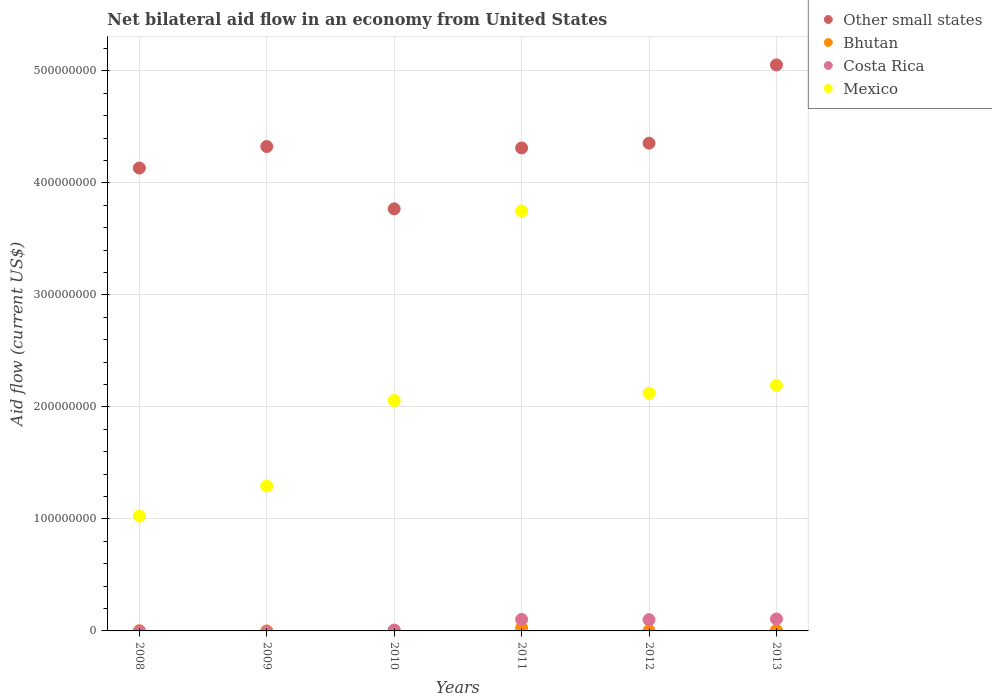How many different coloured dotlines are there?
Offer a terse response. 4. What is the net bilateral aid flow in Other small states in 2013?
Your answer should be compact. 5.05e+08. Across all years, what is the maximum net bilateral aid flow in Costa Rica?
Give a very brief answer. 1.07e+07. Across all years, what is the minimum net bilateral aid flow in Mexico?
Your answer should be very brief. 1.03e+08. What is the total net bilateral aid flow in Costa Rica in the graph?
Keep it short and to the point. 3.17e+07. What is the difference between the net bilateral aid flow in Costa Rica in 2011 and the net bilateral aid flow in Mexico in 2010?
Make the answer very short. -1.95e+08. What is the average net bilateral aid flow in Other small states per year?
Keep it short and to the point. 4.32e+08. In the year 2010, what is the difference between the net bilateral aid flow in Costa Rica and net bilateral aid flow in Mexico?
Give a very brief answer. -2.05e+08. In how many years, is the net bilateral aid flow in Mexico greater than 120000000 US$?
Your answer should be compact. 5. What is the ratio of the net bilateral aid flow in Costa Rica in 2011 to that in 2013?
Your answer should be compact. 0.96. What is the difference between the highest and the second highest net bilateral aid flow in Costa Rica?
Provide a succinct answer. 4.20e+05. What is the difference between the highest and the lowest net bilateral aid flow in Bhutan?
Make the answer very short. 2.65e+06. Is it the case that in every year, the sum of the net bilateral aid flow in Mexico and net bilateral aid flow in Costa Rica  is greater than the net bilateral aid flow in Bhutan?
Your answer should be very brief. Yes. Does the net bilateral aid flow in Bhutan monotonically increase over the years?
Keep it short and to the point. No. Is the net bilateral aid flow in Mexico strictly greater than the net bilateral aid flow in Bhutan over the years?
Provide a short and direct response. Yes. Is the net bilateral aid flow in Mexico strictly less than the net bilateral aid flow in Bhutan over the years?
Your answer should be very brief. No. What is the difference between two consecutive major ticks on the Y-axis?
Provide a succinct answer. 1.00e+08. Are the values on the major ticks of Y-axis written in scientific E-notation?
Make the answer very short. No. Does the graph contain grids?
Offer a terse response. Yes. What is the title of the graph?
Give a very brief answer. Net bilateral aid flow in an economy from United States. What is the label or title of the X-axis?
Provide a short and direct response. Years. What is the label or title of the Y-axis?
Provide a short and direct response. Aid flow (current US$). What is the Aid flow (current US$) of Other small states in 2008?
Provide a short and direct response. 4.13e+08. What is the Aid flow (current US$) of Bhutan in 2008?
Offer a terse response. 2.40e+05. What is the Aid flow (current US$) of Costa Rica in 2008?
Provide a short and direct response. 0. What is the Aid flow (current US$) of Mexico in 2008?
Your response must be concise. 1.03e+08. What is the Aid flow (current US$) in Other small states in 2009?
Ensure brevity in your answer.  4.32e+08. What is the Aid flow (current US$) of Bhutan in 2009?
Give a very brief answer. 10000. What is the Aid flow (current US$) in Costa Rica in 2009?
Make the answer very short. 0. What is the Aid flow (current US$) of Mexico in 2009?
Ensure brevity in your answer.  1.29e+08. What is the Aid flow (current US$) of Other small states in 2010?
Provide a short and direct response. 3.77e+08. What is the Aid flow (current US$) of Bhutan in 2010?
Provide a short and direct response. 6.20e+05. What is the Aid flow (current US$) in Costa Rica in 2010?
Ensure brevity in your answer.  6.90e+05. What is the Aid flow (current US$) in Mexico in 2010?
Offer a terse response. 2.06e+08. What is the Aid flow (current US$) in Other small states in 2011?
Your response must be concise. 4.31e+08. What is the Aid flow (current US$) of Bhutan in 2011?
Provide a short and direct response. 2.66e+06. What is the Aid flow (current US$) in Costa Rica in 2011?
Ensure brevity in your answer.  1.03e+07. What is the Aid flow (current US$) of Mexico in 2011?
Provide a succinct answer. 3.75e+08. What is the Aid flow (current US$) in Other small states in 2012?
Make the answer very short. 4.35e+08. What is the Aid flow (current US$) of Bhutan in 2012?
Ensure brevity in your answer.  3.00e+05. What is the Aid flow (current US$) of Costa Rica in 2012?
Provide a short and direct response. 1.01e+07. What is the Aid flow (current US$) in Mexico in 2012?
Keep it short and to the point. 2.12e+08. What is the Aid flow (current US$) in Other small states in 2013?
Your answer should be compact. 5.05e+08. What is the Aid flow (current US$) in Bhutan in 2013?
Keep it short and to the point. 5.70e+05. What is the Aid flow (current US$) in Costa Rica in 2013?
Provide a short and direct response. 1.07e+07. What is the Aid flow (current US$) of Mexico in 2013?
Provide a succinct answer. 2.19e+08. Across all years, what is the maximum Aid flow (current US$) in Other small states?
Give a very brief answer. 5.05e+08. Across all years, what is the maximum Aid flow (current US$) of Bhutan?
Keep it short and to the point. 2.66e+06. Across all years, what is the maximum Aid flow (current US$) in Costa Rica?
Your response must be concise. 1.07e+07. Across all years, what is the maximum Aid flow (current US$) of Mexico?
Your answer should be compact. 3.75e+08. Across all years, what is the minimum Aid flow (current US$) in Other small states?
Make the answer very short. 3.77e+08. Across all years, what is the minimum Aid flow (current US$) of Costa Rica?
Provide a short and direct response. 0. Across all years, what is the minimum Aid flow (current US$) in Mexico?
Your answer should be very brief. 1.03e+08. What is the total Aid flow (current US$) of Other small states in the graph?
Provide a succinct answer. 2.59e+09. What is the total Aid flow (current US$) of Bhutan in the graph?
Your answer should be compact. 4.40e+06. What is the total Aid flow (current US$) of Costa Rica in the graph?
Your answer should be compact. 3.17e+07. What is the total Aid flow (current US$) in Mexico in the graph?
Your answer should be very brief. 1.24e+09. What is the difference between the Aid flow (current US$) in Other small states in 2008 and that in 2009?
Your answer should be compact. -1.92e+07. What is the difference between the Aid flow (current US$) of Mexico in 2008 and that in 2009?
Offer a terse response. -2.69e+07. What is the difference between the Aid flow (current US$) of Other small states in 2008 and that in 2010?
Your answer should be compact. 3.64e+07. What is the difference between the Aid flow (current US$) of Bhutan in 2008 and that in 2010?
Offer a very short reply. -3.80e+05. What is the difference between the Aid flow (current US$) in Mexico in 2008 and that in 2010?
Your answer should be very brief. -1.03e+08. What is the difference between the Aid flow (current US$) of Other small states in 2008 and that in 2011?
Ensure brevity in your answer.  -1.79e+07. What is the difference between the Aid flow (current US$) of Bhutan in 2008 and that in 2011?
Give a very brief answer. -2.42e+06. What is the difference between the Aid flow (current US$) in Mexico in 2008 and that in 2011?
Keep it short and to the point. -2.72e+08. What is the difference between the Aid flow (current US$) of Other small states in 2008 and that in 2012?
Offer a very short reply. -2.22e+07. What is the difference between the Aid flow (current US$) in Bhutan in 2008 and that in 2012?
Give a very brief answer. -6.00e+04. What is the difference between the Aid flow (current US$) of Mexico in 2008 and that in 2012?
Make the answer very short. -1.10e+08. What is the difference between the Aid flow (current US$) of Other small states in 2008 and that in 2013?
Give a very brief answer. -9.20e+07. What is the difference between the Aid flow (current US$) of Bhutan in 2008 and that in 2013?
Ensure brevity in your answer.  -3.30e+05. What is the difference between the Aid flow (current US$) of Mexico in 2008 and that in 2013?
Offer a terse response. -1.17e+08. What is the difference between the Aid flow (current US$) of Other small states in 2009 and that in 2010?
Your answer should be compact. 5.56e+07. What is the difference between the Aid flow (current US$) of Bhutan in 2009 and that in 2010?
Ensure brevity in your answer.  -6.10e+05. What is the difference between the Aid flow (current US$) in Mexico in 2009 and that in 2010?
Give a very brief answer. -7.62e+07. What is the difference between the Aid flow (current US$) of Other small states in 2009 and that in 2011?
Offer a very short reply. 1.28e+06. What is the difference between the Aid flow (current US$) in Bhutan in 2009 and that in 2011?
Keep it short and to the point. -2.65e+06. What is the difference between the Aid flow (current US$) in Mexico in 2009 and that in 2011?
Keep it short and to the point. -2.45e+08. What is the difference between the Aid flow (current US$) of Other small states in 2009 and that in 2012?
Your answer should be compact. -2.97e+06. What is the difference between the Aid flow (current US$) in Bhutan in 2009 and that in 2012?
Provide a short and direct response. -2.90e+05. What is the difference between the Aid flow (current US$) of Mexico in 2009 and that in 2012?
Give a very brief answer. -8.27e+07. What is the difference between the Aid flow (current US$) in Other small states in 2009 and that in 2013?
Keep it short and to the point. -7.28e+07. What is the difference between the Aid flow (current US$) in Bhutan in 2009 and that in 2013?
Make the answer very short. -5.60e+05. What is the difference between the Aid flow (current US$) of Mexico in 2009 and that in 2013?
Your answer should be very brief. -8.97e+07. What is the difference between the Aid flow (current US$) in Other small states in 2010 and that in 2011?
Your response must be concise. -5.44e+07. What is the difference between the Aid flow (current US$) of Bhutan in 2010 and that in 2011?
Offer a terse response. -2.04e+06. What is the difference between the Aid flow (current US$) in Costa Rica in 2010 and that in 2011?
Your answer should be very brief. -9.57e+06. What is the difference between the Aid flow (current US$) in Mexico in 2010 and that in 2011?
Offer a terse response. -1.69e+08. What is the difference between the Aid flow (current US$) of Other small states in 2010 and that in 2012?
Make the answer very short. -5.86e+07. What is the difference between the Aid flow (current US$) in Costa Rica in 2010 and that in 2012?
Ensure brevity in your answer.  -9.37e+06. What is the difference between the Aid flow (current US$) in Mexico in 2010 and that in 2012?
Your answer should be very brief. -6.54e+06. What is the difference between the Aid flow (current US$) in Other small states in 2010 and that in 2013?
Provide a succinct answer. -1.28e+08. What is the difference between the Aid flow (current US$) of Costa Rica in 2010 and that in 2013?
Make the answer very short. -9.99e+06. What is the difference between the Aid flow (current US$) of Mexico in 2010 and that in 2013?
Offer a very short reply. -1.36e+07. What is the difference between the Aid flow (current US$) in Other small states in 2011 and that in 2012?
Make the answer very short. -4.25e+06. What is the difference between the Aid flow (current US$) of Bhutan in 2011 and that in 2012?
Keep it short and to the point. 2.36e+06. What is the difference between the Aid flow (current US$) in Mexico in 2011 and that in 2012?
Keep it short and to the point. 1.63e+08. What is the difference between the Aid flow (current US$) in Other small states in 2011 and that in 2013?
Your answer should be compact. -7.41e+07. What is the difference between the Aid flow (current US$) of Bhutan in 2011 and that in 2013?
Your response must be concise. 2.09e+06. What is the difference between the Aid flow (current US$) of Costa Rica in 2011 and that in 2013?
Give a very brief answer. -4.20e+05. What is the difference between the Aid flow (current US$) in Mexico in 2011 and that in 2013?
Give a very brief answer. 1.56e+08. What is the difference between the Aid flow (current US$) in Other small states in 2012 and that in 2013?
Provide a short and direct response. -6.99e+07. What is the difference between the Aid flow (current US$) in Bhutan in 2012 and that in 2013?
Give a very brief answer. -2.70e+05. What is the difference between the Aid flow (current US$) of Costa Rica in 2012 and that in 2013?
Give a very brief answer. -6.20e+05. What is the difference between the Aid flow (current US$) of Mexico in 2012 and that in 2013?
Offer a very short reply. -7.01e+06. What is the difference between the Aid flow (current US$) in Other small states in 2008 and the Aid flow (current US$) in Bhutan in 2009?
Provide a succinct answer. 4.13e+08. What is the difference between the Aid flow (current US$) of Other small states in 2008 and the Aid flow (current US$) of Mexico in 2009?
Your response must be concise. 2.84e+08. What is the difference between the Aid flow (current US$) in Bhutan in 2008 and the Aid flow (current US$) in Mexico in 2009?
Provide a short and direct response. -1.29e+08. What is the difference between the Aid flow (current US$) of Other small states in 2008 and the Aid flow (current US$) of Bhutan in 2010?
Keep it short and to the point. 4.13e+08. What is the difference between the Aid flow (current US$) in Other small states in 2008 and the Aid flow (current US$) in Costa Rica in 2010?
Offer a terse response. 4.13e+08. What is the difference between the Aid flow (current US$) of Other small states in 2008 and the Aid flow (current US$) of Mexico in 2010?
Your answer should be compact. 2.08e+08. What is the difference between the Aid flow (current US$) in Bhutan in 2008 and the Aid flow (current US$) in Costa Rica in 2010?
Ensure brevity in your answer.  -4.50e+05. What is the difference between the Aid flow (current US$) in Bhutan in 2008 and the Aid flow (current US$) in Mexico in 2010?
Your answer should be very brief. -2.05e+08. What is the difference between the Aid flow (current US$) of Other small states in 2008 and the Aid flow (current US$) of Bhutan in 2011?
Your answer should be very brief. 4.11e+08. What is the difference between the Aid flow (current US$) of Other small states in 2008 and the Aid flow (current US$) of Costa Rica in 2011?
Your answer should be compact. 4.03e+08. What is the difference between the Aid flow (current US$) of Other small states in 2008 and the Aid flow (current US$) of Mexico in 2011?
Provide a short and direct response. 3.83e+07. What is the difference between the Aid flow (current US$) in Bhutan in 2008 and the Aid flow (current US$) in Costa Rica in 2011?
Your response must be concise. -1.00e+07. What is the difference between the Aid flow (current US$) in Bhutan in 2008 and the Aid flow (current US$) in Mexico in 2011?
Offer a terse response. -3.75e+08. What is the difference between the Aid flow (current US$) in Other small states in 2008 and the Aid flow (current US$) in Bhutan in 2012?
Make the answer very short. 4.13e+08. What is the difference between the Aid flow (current US$) of Other small states in 2008 and the Aid flow (current US$) of Costa Rica in 2012?
Keep it short and to the point. 4.03e+08. What is the difference between the Aid flow (current US$) in Other small states in 2008 and the Aid flow (current US$) in Mexico in 2012?
Ensure brevity in your answer.  2.01e+08. What is the difference between the Aid flow (current US$) of Bhutan in 2008 and the Aid flow (current US$) of Costa Rica in 2012?
Give a very brief answer. -9.82e+06. What is the difference between the Aid flow (current US$) of Bhutan in 2008 and the Aid flow (current US$) of Mexico in 2012?
Provide a short and direct response. -2.12e+08. What is the difference between the Aid flow (current US$) in Other small states in 2008 and the Aid flow (current US$) in Bhutan in 2013?
Your answer should be very brief. 4.13e+08. What is the difference between the Aid flow (current US$) of Other small states in 2008 and the Aid flow (current US$) of Costa Rica in 2013?
Provide a short and direct response. 4.03e+08. What is the difference between the Aid flow (current US$) in Other small states in 2008 and the Aid flow (current US$) in Mexico in 2013?
Give a very brief answer. 1.94e+08. What is the difference between the Aid flow (current US$) of Bhutan in 2008 and the Aid flow (current US$) of Costa Rica in 2013?
Provide a succinct answer. -1.04e+07. What is the difference between the Aid flow (current US$) of Bhutan in 2008 and the Aid flow (current US$) of Mexico in 2013?
Offer a very short reply. -2.19e+08. What is the difference between the Aid flow (current US$) in Other small states in 2009 and the Aid flow (current US$) in Bhutan in 2010?
Make the answer very short. 4.32e+08. What is the difference between the Aid flow (current US$) in Other small states in 2009 and the Aid flow (current US$) in Costa Rica in 2010?
Provide a short and direct response. 4.32e+08. What is the difference between the Aid flow (current US$) of Other small states in 2009 and the Aid flow (current US$) of Mexico in 2010?
Keep it short and to the point. 2.27e+08. What is the difference between the Aid flow (current US$) of Bhutan in 2009 and the Aid flow (current US$) of Costa Rica in 2010?
Your response must be concise. -6.80e+05. What is the difference between the Aid flow (current US$) in Bhutan in 2009 and the Aid flow (current US$) in Mexico in 2010?
Give a very brief answer. -2.06e+08. What is the difference between the Aid flow (current US$) in Other small states in 2009 and the Aid flow (current US$) in Bhutan in 2011?
Keep it short and to the point. 4.30e+08. What is the difference between the Aid flow (current US$) of Other small states in 2009 and the Aid flow (current US$) of Costa Rica in 2011?
Your answer should be compact. 4.22e+08. What is the difference between the Aid flow (current US$) in Other small states in 2009 and the Aid flow (current US$) in Mexico in 2011?
Give a very brief answer. 5.75e+07. What is the difference between the Aid flow (current US$) in Bhutan in 2009 and the Aid flow (current US$) in Costa Rica in 2011?
Offer a terse response. -1.02e+07. What is the difference between the Aid flow (current US$) in Bhutan in 2009 and the Aid flow (current US$) in Mexico in 2011?
Provide a short and direct response. -3.75e+08. What is the difference between the Aid flow (current US$) in Other small states in 2009 and the Aid flow (current US$) in Bhutan in 2012?
Make the answer very short. 4.32e+08. What is the difference between the Aid flow (current US$) in Other small states in 2009 and the Aid flow (current US$) in Costa Rica in 2012?
Keep it short and to the point. 4.22e+08. What is the difference between the Aid flow (current US$) of Other small states in 2009 and the Aid flow (current US$) of Mexico in 2012?
Provide a short and direct response. 2.20e+08. What is the difference between the Aid flow (current US$) in Bhutan in 2009 and the Aid flow (current US$) in Costa Rica in 2012?
Your answer should be compact. -1.00e+07. What is the difference between the Aid flow (current US$) of Bhutan in 2009 and the Aid flow (current US$) of Mexico in 2012?
Provide a short and direct response. -2.12e+08. What is the difference between the Aid flow (current US$) in Other small states in 2009 and the Aid flow (current US$) in Bhutan in 2013?
Provide a succinct answer. 4.32e+08. What is the difference between the Aid flow (current US$) in Other small states in 2009 and the Aid flow (current US$) in Costa Rica in 2013?
Ensure brevity in your answer.  4.22e+08. What is the difference between the Aid flow (current US$) in Other small states in 2009 and the Aid flow (current US$) in Mexico in 2013?
Give a very brief answer. 2.13e+08. What is the difference between the Aid flow (current US$) in Bhutan in 2009 and the Aid flow (current US$) in Costa Rica in 2013?
Your answer should be very brief. -1.07e+07. What is the difference between the Aid flow (current US$) in Bhutan in 2009 and the Aid flow (current US$) in Mexico in 2013?
Make the answer very short. -2.19e+08. What is the difference between the Aid flow (current US$) of Other small states in 2010 and the Aid flow (current US$) of Bhutan in 2011?
Offer a very short reply. 3.74e+08. What is the difference between the Aid flow (current US$) in Other small states in 2010 and the Aid flow (current US$) in Costa Rica in 2011?
Offer a terse response. 3.66e+08. What is the difference between the Aid flow (current US$) of Other small states in 2010 and the Aid flow (current US$) of Mexico in 2011?
Provide a short and direct response. 1.87e+06. What is the difference between the Aid flow (current US$) in Bhutan in 2010 and the Aid flow (current US$) in Costa Rica in 2011?
Your response must be concise. -9.64e+06. What is the difference between the Aid flow (current US$) of Bhutan in 2010 and the Aid flow (current US$) of Mexico in 2011?
Make the answer very short. -3.74e+08. What is the difference between the Aid flow (current US$) in Costa Rica in 2010 and the Aid flow (current US$) in Mexico in 2011?
Make the answer very short. -3.74e+08. What is the difference between the Aid flow (current US$) in Other small states in 2010 and the Aid flow (current US$) in Bhutan in 2012?
Offer a terse response. 3.76e+08. What is the difference between the Aid flow (current US$) of Other small states in 2010 and the Aid flow (current US$) of Costa Rica in 2012?
Ensure brevity in your answer.  3.67e+08. What is the difference between the Aid flow (current US$) in Other small states in 2010 and the Aid flow (current US$) in Mexico in 2012?
Keep it short and to the point. 1.65e+08. What is the difference between the Aid flow (current US$) of Bhutan in 2010 and the Aid flow (current US$) of Costa Rica in 2012?
Your answer should be very brief. -9.44e+06. What is the difference between the Aid flow (current US$) in Bhutan in 2010 and the Aid flow (current US$) in Mexico in 2012?
Ensure brevity in your answer.  -2.12e+08. What is the difference between the Aid flow (current US$) of Costa Rica in 2010 and the Aid flow (current US$) of Mexico in 2012?
Make the answer very short. -2.11e+08. What is the difference between the Aid flow (current US$) of Other small states in 2010 and the Aid flow (current US$) of Bhutan in 2013?
Make the answer very short. 3.76e+08. What is the difference between the Aid flow (current US$) of Other small states in 2010 and the Aid flow (current US$) of Costa Rica in 2013?
Make the answer very short. 3.66e+08. What is the difference between the Aid flow (current US$) of Other small states in 2010 and the Aid flow (current US$) of Mexico in 2013?
Your answer should be very brief. 1.58e+08. What is the difference between the Aid flow (current US$) in Bhutan in 2010 and the Aid flow (current US$) in Costa Rica in 2013?
Your response must be concise. -1.01e+07. What is the difference between the Aid flow (current US$) in Bhutan in 2010 and the Aid flow (current US$) in Mexico in 2013?
Make the answer very short. -2.19e+08. What is the difference between the Aid flow (current US$) in Costa Rica in 2010 and the Aid flow (current US$) in Mexico in 2013?
Offer a very short reply. -2.18e+08. What is the difference between the Aid flow (current US$) of Other small states in 2011 and the Aid flow (current US$) of Bhutan in 2012?
Make the answer very short. 4.31e+08. What is the difference between the Aid flow (current US$) of Other small states in 2011 and the Aid flow (current US$) of Costa Rica in 2012?
Provide a short and direct response. 4.21e+08. What is the difference between the Aid flow (current US$) of Other small states in 2011 and the Aid flow (current US$) of Mexico in 2012?
Your answer should be very brief. 2.19e+08. What is the difference between the Aid flow (current US$) in Bhutan in 2011 and the Aid flow (current US$) in Costa Rica in 2012?
Ensure brevity in your answer.  -7.40e+06. What is the difference between the Aid flow (current US$) of Bhutan in 2011 and the Aid flow (current US$) of Mexico in 2012?
Provide a succinct answer. -2.09e+08. What is the difference between the Aid flow (current US$) in Costa Rica in 2011 and the Aid flow (current US$) in Mexico in 2012?
Ensure brevity in your answer.  -2.02e+08. What is the difference between the Aid flow (current US$) in Other small states in 2011 and the Aid flow (current US$) in Bhutan in 2013?
Your answer should be very brief. 4.31e+08. What is the difference between the Aid flow (current US$) in Other small states in 2011 and the Aid flow (current US$) in Costa Rica in 2013?
Offer a terse response. 4.20e+08. What is the difference between the Aid flow (current US$) in Other small states in 2011 and the Aid flow (current US$) in Mexico in 2013?
Your answer should be very brief. 2.12e+08. What is the difference between the Aid flow (current US$) in Bhutan in 2011 and the Aid flow (current US$) in Costa Rica in 2013?
Give a very brief answer. -8.02e+06. What is the difference between the Aid flow (current US$) in Bhutan in 2011 and the Aid flow (current US$) in Mexico in 2013?
Your answer should be very brief. -2.16e+08. What is the difference between the Aid flow (current US$) of Costa Rica in 2011 and the Aid flow (current US$) of Mexico in 2013?
Offer a very short reply. -2.09e+08. What is the difference between the Aid flow (current US$) of Other small states in 2012 and the Aid flow (current US$) of Bhutan in 2013?
Provide a short and direct response. 4.35e+08. What is the difference between the Aid flow (current US$) in Other small states in 2012 and the Aid flow (current US$) in Costa Rica in 2013?
Offer a terse response. 4.25e+08. What is the difference between the Aid flow (current US$) in Other small states in 2012 and the Aid flow (current US$) in Mexico in 2013?
Make the answer very short. 2.16e+08. What is the difference between the Aid flow (current US$) in Bhutan in 2012 and the Aid flow (current US$) in Costa Rica in 2013?
Give a very brief answer. -1.04e+07. What is the difference between the Aid flow (current US$) in Bhutan in 2012 and the Aid flow (current US$) in Mexico in 2013?
Give a very brief answer. -2.19e+08. What is the difference between the Aid flow (current US$) in Costa Rica in 2012 and the Aid flow (current US$) in Mexico in 2013?
Make the answer very short. -2.09e+08. What is the average Aid flow (current US$) of Other small states per year?
Provide a short and direct response. 4.32e+08. What is the average Aid flow (current US$) of Bhutan per year?
Your answer should be compact. 7.33e+05. What is the average Aid flow (current US$) in Costa Rica per year?
Ensure brevity in your answer.  5.28e+06. What is the average Aid flow (current US$) in Mexico per year?
Give a very brief answer. 2.07e+08. In the year 2008, what is the difference between the Aid flow (current US$) of Other small states and Aid flow (current US$) of Bhutan?
Ensure brevity in your answer.  4.13e+08. In the year 2008, what is the difference between the Aid flow (current US$) of Other small states and Aid flow (current US$) of Mexico?
Your response must be concise. 3.11e+08. In the year 2008, what is the difference between the Aid flow (current US$) in Bhutan and Aid flow (current US$) in Mexico?
Make the answer very short. -1.02e+08. In the year 2009, what is the difference between the Aid flow (current US$) in Other small states and Aid flow (current US$) in Bhutan?
Your response must be concise. 4.32e+08. In the year 2009, what is the difference between the Aid flow (current US$) in Other small states and Aid flow (current US$) in Mexico?
Offer a very short reply. 3.03e+08. In the year 2009, what is the difference between the Aid flow (current US$) in Bhutan and Aid flow (current US$) in Mexico?
Give a very brief answer. -1.29e+08. In the year 2010, what is the difference between the Aid flow (current US$) of Other small states and Aid flow (current US$) of Bhutan?
Offer a very short reply. 3.76e+08. In the year 2010, what is the difference between the Aid flow (current US$) of Other small states and Aid flow (current US$) of Costa Rica?
Your response must be concise. 3.76e+08. In the year 2010, what is the difference between the Aid flow (current US$) of Other small states and Aid flow (current US$) of Mexico?
Offer a terse response. 1.71e+08. In the year 2010, what is the difference between the Aid flow (current US$) of Bhutan and Aid flow (current US$) of Costa Rica?
Provide a short and direct response. -7.00e+04. In the year 2010, what is the difference between the Aid flow (current US$) in Bhutan and Aid flow (current US$) in Mexico?
Offer a very short reply. -2.05e+08. In the year 2010, what is the difference between the Aid flow (current US$) of Costa Rica and Aid flow (current US$) of Mexico?
Your answer should be very brief. -2.05e+08. In the year 2011, what is the difference between the Aid flow (current US$) in Other small states and Aid flow (current US$) in Bhutan?
Provide a succinct answer. 4.28e+08. In the year 2011, what is the difference between the Aid flow (current US$) in Other small states and Aid flow (current US$) in Costa Rica?
Make the answer very short. 4.21e+08. In the year 2011, what is the difference between the Aid flow (current US$) in Other small states and Aid flow (current US$) in Mexico?
Your answer should be compact. 5.62e+07. In the year 2011, what is the difference between the Aid flow (current US$) of Bhutan and Aid flow (current US$) of Costa Rica?
Provide a succinct answer. -7.60e+06. In the year 2011, what is the difference between the Aid flow (current US$) in Bhutan and Aid flow (current US$) in Mexico?
Offer a terse response. -3.72e+08. In the year 2011, what is the difference between the Aid flow (current US$) in Costa Rica and Aid flow (current US$) in Mexico?
Ensure brevity in your answer.  -3.65e+08. In the year 2012, what is the difference between the Aid flow (current US$) of Other small states and Aid flow (current US$) of Bhutan?
Offer a very short reply. 4.35e+08. In the year 2012, what is the difference between the Aid flow (current US$) in Other small states and Aid flow (current US$) in Costa Rica?
Your answer should be very brief. 4.25e+08. In the year 2012, what is the difference between the Aid flow (current US$) of Other small states and Aid flow (current US$) of Mexico?
Your answer should be compact. 2.23e+08. In the year 2012, what is the difference between the Aid flow (current US$) of Bhutan and Aid flow (current US$) of Costa Rica?
Give a very brief answer. -9.76e+06. In the year 2012, what is the difference between the Aid flow (current US$) of Bhutan and Aid flow (current US$) of Mexico?
Keep it short and to the point. -2.12e+08. In the year 2012, what is the difference between the Aid flow (current US$) in Costa Rica and Aid flow (current US$) in Mexico?
Your response must be concise. -2.02e+08. In the year 2013, what is the difference between the Aid flow (current US$) of Other small states and Aid flow (current US$) of Bhutan?
Offer a terse response. 5.05e+08. In the year 2013, what is the difference between the Aid flow (current US$) in Other small states and Aid flow (current US$) in Costa Rica?
Offer a terse response. 4.95e+08. In the year 2013, what is the difference between the Aid flow (current US$) in Other small states and Aid flow (current US$) in Mexico?
Your answer should be very brief. 2.86e+08. In the year 2013, what is the difference between the Aid flow (current US$) in Bhutan and Aid flow (current US$) in Costa Rica?
Offer a very short reply. -1.01e+07. In the year 2013, what is the difference between the Aid flow (current US$) in Bhutan and Aid flow (current US$) in Mexico?
Provide a short and direct response. -2.19e+08. In the year 2013, what is the difference between the Aid flow (current US$) of Costa Rica and Aid flow (current US$) of Mexico?
Ensure brevity in your answer.  -2.08e+08. What is the ratio of the Aid flow (current US$) of Other small states in 2008 to that in 2009?
Keep it short and to the point. 0.96. What is the ratio of the Aid flow (current US$) of Mexico in 2008 to that in 2009?
Your response must be concise. 0.79. What is the ratio of the Aid flow (current US$) of Other small states in 2008 to that in 2010?
Offer a terse response. 1.1. What is the ratio of the Aid flow (current US$) of Bhutan in 2008 to that in 2010?
Give a very brief answer. 0.39. What is the ratio of the Aid flow (current US$) of Mexico in 2008 to that in 2010?
Provide a short and direct response. 0.5. What is the ratio of the Aid flow (current US$) of Other small states in 2008 to that in 2011?
Ensure brevity in your answer.  0.96. What is the ratio of the Aid flow (current US$) in Bhutan in 2008 to that in 2011?
Provide a short and direct response. 0.09. What is the ratio of the Aid flow (current US$) of Mexico in 2008 to that in 2011?
Provide a short and direct response. 0.27. What is the ratio of the Aid flow (current US$) of Other small states in 2008 to that in 2012?
Keep it short and to the point. 0.95. What is the ratio of the Aid flow (current US$) in Mexico in 2008 to that in 2012?
Keep it short and to the point. 0.48. What is the ratio of the Aid flow (current US$) in Other small states in 2008 to that in 2013?
Your answer should be very brief. 0.82. What is the ratio of the Aid flow (current US$) of Bhutan in 2008 to that in 2013?
Your response must be concise. 0.42. What is the ratio of the Aid flow (current US$) of Mexico in 2008 to that in 2013?
Your answer should be very brief. 0.47. What is the ratio of the Aid flow (current US$) of Other small states in 2009 to that in 2010?
Give a very brief answer. 1.15. What is the ratio of the Aid flow (current US$) in Bhutan in 2009 to that in 2010?
Your answer should be very brief. 0.02. What is the ratio of the Aid flow (current US$) in Mexico in 2009 to that in 2010?
Your answer should be compact. 0.63. What is the ratio of the Aid flow (current US$) in Bhutan in 2009 to that in 2011?
Keep it short and to the point. 0. What is the ratio of the Aid flow (current US$) in Mexico in 2009 to that in 2011?
Your answer should be compact. 0.35. What is the ratio of the Aid flow (current US$) in Other small states in 2009 to that in 2012?
Keep it short and to the point. 0.99. What is the ratio of the Aid flow (current US$) in Bhutan in 2009 to that in 2012?
Keep it short and to the point. 0.03. What is the ratio of the Aid flow (current US$) of Mexico in 2009 to that in 2012?
Provide a short and direct response. 0.61. What is the ratio of the Aid flow (current US$) in Other small states in 2009 to that in 2013?
Provide a short and direct response. 0.86. What is the ratio of the Aid flow (current US$) in Bhutan in 2009 to that in 2013?
Provide a succinct answer. 0.02. What is the ratio of the Aid flow (current US$) of Mexico in 2009 to that in 2013?
Your response must be concise. 0.59. What is the ratio of the Aid flow (current US$) of Other small states in 2010 to that in 2011?
Provide a succinct answer. 0.87. What is the ratio of the Aid flow (current US$) of Bhutan in 2010 to that in 2011?
Offer a very short reply. 0.23. What is the ratio of the Aid flow (current US$) in Costa Rica in 2010 to that in 2011?
Offer a terse response. 0.07. What is the ratio of the Aid flow (current US$) in Mexico in 2010 to that in 2011?
Provide a succinct answer. 0.55. What is the ratio of the Aid flow (current US$) in Other small states in 2010 to that in 2012?
Provide a succinct answer. 0.87. What is the ratio of the Aid flow (current US$) in Bhutan in 2010 to that in 2012?
Offer a very short reply. 2.07. What is the ratio of the Aid flow (current US$) of Costa Rica in 2010 to that in 2012?
Your response must be concise. 0.07. What is the ratio of the Aid flow (current US$) in Mexico in 2010 to that in 2012?
Offer a very short reply. 0.97. What is the ratio of the Aid flow (current US$) of Other small states in 2010 to that in 2013?
Give a very brief answer. 0.75. What is the ratio of the Aid flow (current US$) of Bhutan in 2010 to that in 2013?
Your answer should be very brief. 1.09. What is the ratio of the Aid flow (current US$) of Costa Rica in 2010 to that in 2013?
Your answer should be very brief. 0.06. What is the ratio of the Aid flow (current US$) in Mexico in 2010 to that in 2013?
Make the answer very short. 0.94. What is the ratio of the Aid flow (current US$) in Other small states in 2011 to that in 2012?
Offer a terse response. 0.99. What is the ratio of the Aid flow (current US$) in Bhutan in 2011 to that in 2012?
Give a very brief answer. 8.87. What is the ratio of the Aid flow (current US$) of Costa Rica in 2011 to that in 2012?
Offer a very short reply. 1.02. What is the ratio of the Aid flow (current US$) in Mexico in 2011 to that in 2012?
Your answer should be compact. 1.77. What is the ratio of the Aid flow (current US$) of Other small states in 2011 to that in 2013?
Your answer should be very brief. 0.85. What is the ratio of the Aid flow (current US$) in Bhutan in 2011 to that in 2013?
Provide a short and direct response. 4.67. What is the ratio of the Aid flow (current US$) in Costa Rica in 2011 to that in 2013?
Your answer should be compact. 0.96. What is the ratio of the Aid flow (current US$) in Mexico in 2011 to that in 2013?
Your response must be concise. 1.71. What is the ratio of the Aid flow (current US$) of Other small states in 2012 to that in 2013?
Provide a succinct answer. 0.86. What is the ratio of the Aid flow (current US$) in Bhutan in 2012 to that in 2013?
Offer a very short reply. 0.53. What is the ratio of the Aid flow (current US$) of Costa Rica in 2012 to that in 2013?
Provide a short and direct response. 0.94. What is the ratio of the Aid flow (current US$) of Mexico in 2012 to that in 2013?
Your response must be concise. 0.97. What is the difference between the highest and the second highest Aid flow (current US$) of Other small states?
Your answer should be very brief. 6.99e+07. What is the difference between the highest and the second highest Aid flow (current US$) of Bhutan?
Ensure brevity in your answer.  2.04e+06. What is the difference between the highest and the second highest Aid flow (current US$) in Costa Rica?
Your response must be concise. 4.20e+05. What is the difference between the highest and the second highest Aid flow (current US$) of Mexico?
Provide a succinct answer. 1.56e+08. What is the difference between the highest and the lowest Aid flow (current US$) of Other small states?
Your answer should be very brief. 1.28e+08. What is the difference between the highest and the lowest Aid flow (current US$) of Bhutan?
Keep it short and to the point. 2.65e+06. What is the difference between the highest and the lowest Aid flow (current US$) of Costa Rica?
Offer a terse response. 1.07e+07. What is the difference between the highest and the lowest Aid flow (current US$) of Mexico?
Your answer should be very brief. 2.72e+08. 